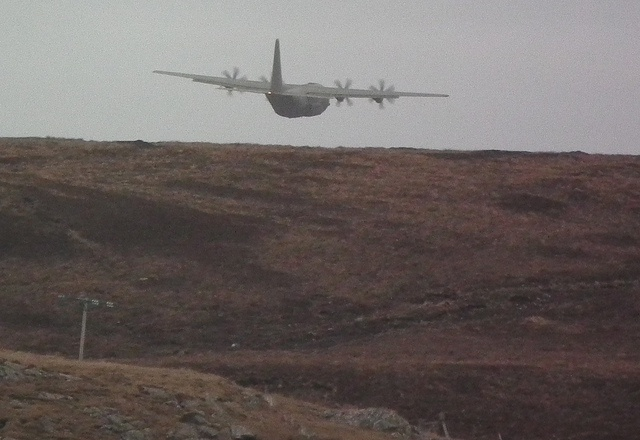Describe the objects in this image and their specific colors. I can see a airplane in darkgray and gray tones in this image. 